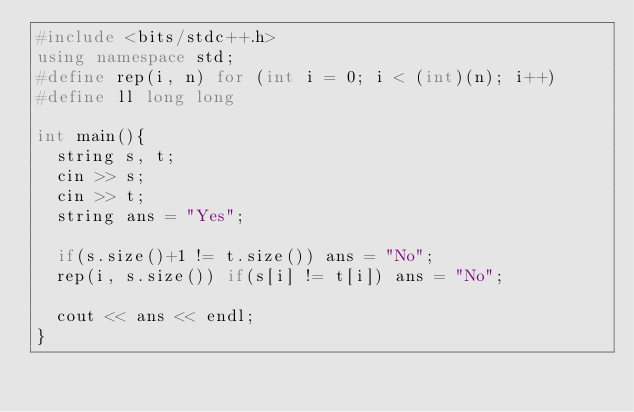Convert code to text. <code><loc_0><loc_0><loc_500><loc_500><_C++_>#include <bits/stdc++.h>
using namespace std;
#define rep(i, n) for (int i = 0; i < (int)(n); i++)
#define ll long long

int main(){
  string s, t;
  cin >> s;
  cin >> t;
  string ans = "Yes";
  
  if(s.size()+1 != t.size()) ans = "No";
  rep(i, s.size()) if(s[i] != t[i]) ans = "No";
  
  cout << ans << endl;
}</code> 